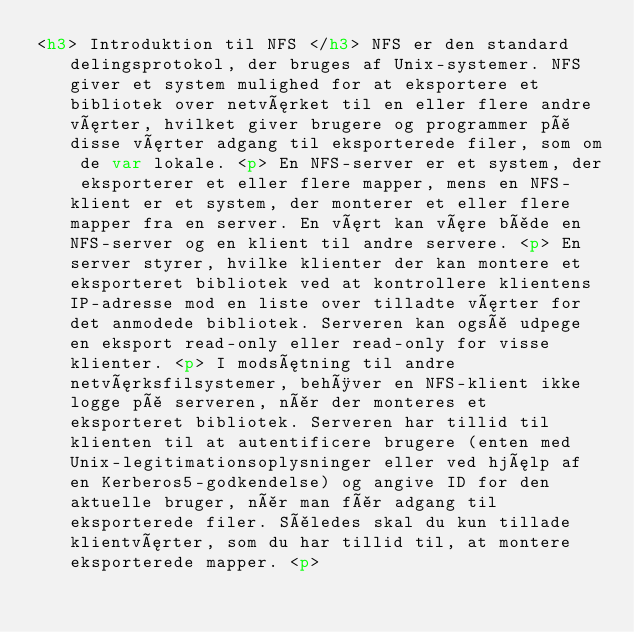Convert code to text. <code><loc_0><loc_0><loc_500><loc_500><_HTML_><h3> Introduktion til NFS </h3> NFS er den standard delingsprotokol, der bruges af Unix-systemer. NFS giver et system mulighed for at eksportere et bibliotek over netværket til en eller flere andre værter, hvilket giver brugere og programmer på disse værter adgang til eksporterede filer, som om de var lokale. <p> En NFS-server er et system, der eksporterer et eller flere mapper, mens en NFS-klient er et system, der monterer et eller flere mapper fra en server. En vært kan være både en NFS-server og en klient til andre servere. <p> En server styrer, hvilke klienter der kan montere et eksporteret bibliotek ved at kontrollere klientens IP-adresse mod en liste over tilladte værter for det anmodede bibliotek. Serveren kan også udpege en eksport read-only eller read-only for visse klienter. <p> I modsætning til andre netværksfilsystemer, behøver en NFS-klient ikke logge på serveren, når der monteres et eksporteret bibliotek. Serveren har tillid til klienten til at autentificere brugere (enten med Unix-legitimationsoplysninger eller ved hjælp af en Kerberos5-godkendelse) og angive ID for den aktuelle bruger, når man får adgang til eksporterede filer. Således skal du kun tillade klientværter, som du har tillid til, at montere eksporterede mapper. <p></code> 